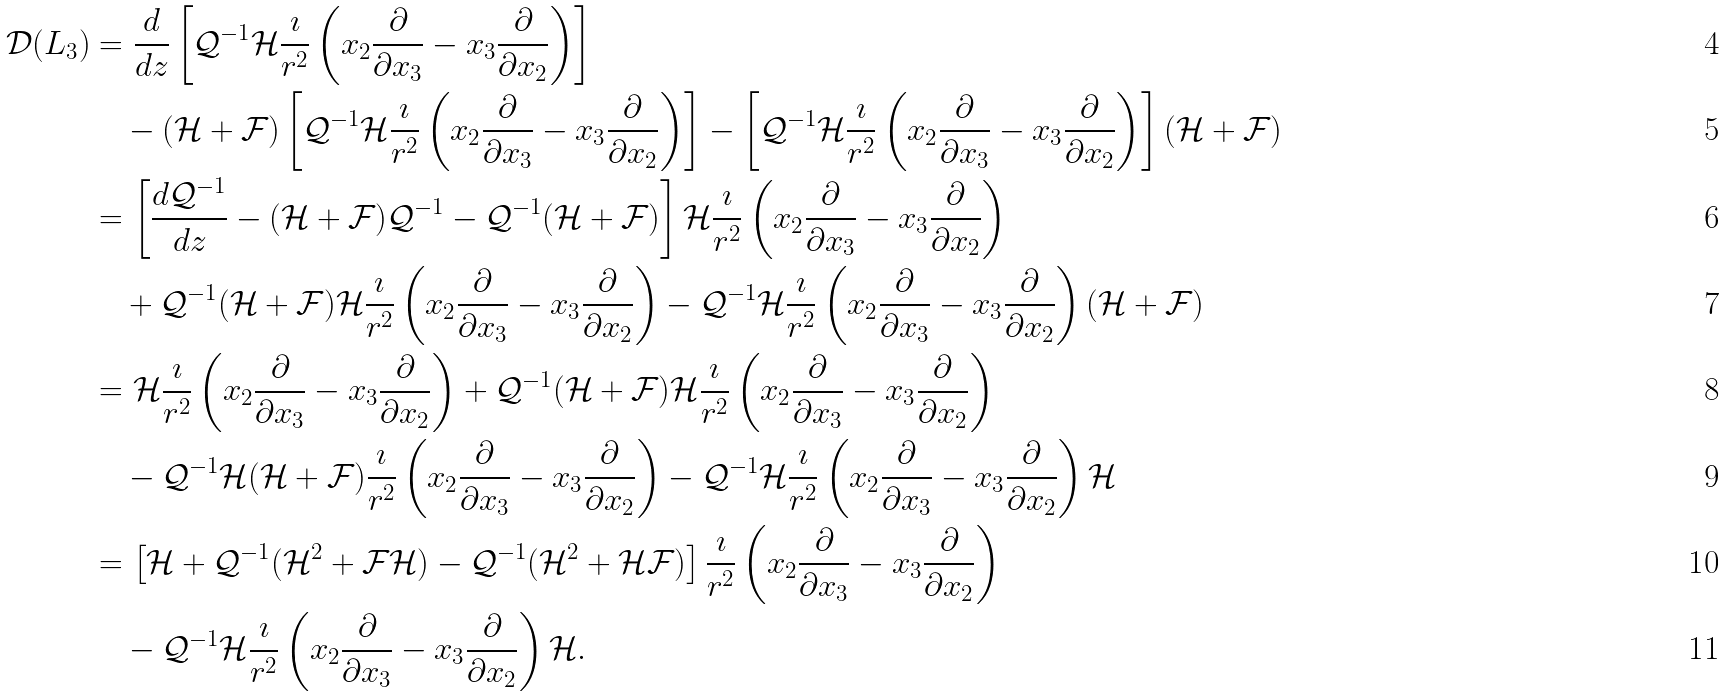Convert formula to latex. <formula><loc_0><loc_0><loc_500><loc_500>\mathcal { D } ( L _ { 3 } ) & = \frac { d } { d z } \left [ \mathcal { Q } ^ { - 1 } \mathcal { H } \frac { \imath } { r ^ { 2 } } \left ( x _ { 2 } \frac { \partial } { \partial x _ { 3 } } - x _ { 3 } \frac { \partial } { \partial x _ { 2 } } \right ) \right ] \\ & \quad - ( \mathcal { H } + \mathcal { F } ) \left [ \mathcal { Q } ^ { - 1 } \mathcal { H } \frac { \imath } { r ^ { 2 } } \left ( x _ { 2 } \frac { \partial } { \partial x _ { 3 } } - x _ { 3 } \frac { \partial } { \partial x _ { 2 } } \right ) \right ] - \left [ \mathcal { Q } ^ { - 1 } \mathcal { H } \frac { \imath } { r ^ { 2 } } \left ( x _ { 2 } \frac { \partial } { \partial x _ { 3 } } - x _ { 3 } \frac { \partial } { \partial x _ { 2 } } \right ) \right ] ( \mathcal { H } + \mathcal { F } ) \\ & = \left [ \frac { d \mathcal { Q } ^ { - 1 } } { d z } - ( \mathcal { H } + \mathcal { F } ) \mathcal { Q } ^ { - 1 } - \mathcal { Q } ^ { - 1 } ( \mathcal { H } + \mathcal { F } ) \right ] \mathcal { H } \frac { \imath } { r ^ { 2 } } \left ( x _ { 2 } \frac { \partial } { \partial x _ { 3 } } - x _ { 3 } \frac { \partial } { \partial x _ { 2 } } \right ) \\ & \quad + \mathcal { Q } ^ { - 1 } ( \mathcal { H } + \mathcal { F } ) \mathcal { H } \frac { \imath } { r ^ { 2 } } \left ( x _ { 2 } \frac { \partial } { \partial x _ { 3 } } - x _ { 3 } \frac { \partial } { \partial x _ { 2 } } \right ) - \mathcal { Q } ^ { - 1 } \mathcal { H } \frac { \imath } { r ^ { 2 } } \left ( x _ { 2 } \frac { \partial } { \partial x _ { 3 } } - x _ { 3 } \frac { \partial } { \partial x _ { 2 } } \right ) ( \mathcal { H } + \mathcal { F } ) \\ & = \mathcal { H } \frac { \imath } { r ^ { 2 } } \left ( x _ { 2 } \frac { \partial } { \partial x _ { 3 } } - x _ { 3 } \frac { \partial } { \partial x _ { 2 } } \right ) + \mathcal { Q } ^ { - 1 } ( \mathcal { H } + \mathcal { F } ) \mathcal { H } \frac { \imath } { r ^ { 2 } } \left ( x _ { 2 } \frac { \partial } { \partial x _ { 3 } } - x _ { 3 } \frac { \partial } { \partial x _ { 2 } } \right ) \\ & \quad - \mathcal { Q } ^ { - 1 } \mathcal { H } ( \mathcal { H } + \mathcal { F } ) \frac { \imath } { r ^ { 2 } } \left ( x _ { 2 } \frac { \partial } { \partial x _ { 3 } } - x _ { 3 } \frac { \partial } { \partial x _ { 2 } } \right ) - \mathcal { Q } ^ { - 1 } \mathcal { H } \frac { \imath } { r ^ { 2 } } \left ( x _ { 2 } \frac { \partial } { \partial x _ { 3 } } - x _ { 3 } \frac { \partial } { \partial x _ { 2 } } \right ) \mathcal { H } \\ & = \left [ \mathcal { H } + \mathcal { Q } ^ { - 1 } ( \mathcal { H } ^ { 2 } + \mathcal { F } \mathcal { H } ) - \mathcal { Q } ^ { - 1 } ( \mathcal { H } ^ { 2 } + \mathcal { H } \mathcal { F } ) \right ] \frac { \imath } { r ^ { 2 } } \left ( x _ { 2 } \frac { \partial } { \partial x _ { 3 } } - x _ { 3 } \frac { \partial } { \partial x _ { 2 } } \right ) \\ & \quad - \mathcal { Q } ^ { - 1 } \mathcal { H } \frac { \imath } { r ^ { 2 } } \left ( x _ { 2 } \frac { \partial } { \partial x _ { 3 } } - x _ { 3 } \frac { \partial } { \partial x _ { 2 } } \right ) \mathcal { H } .</formula> 